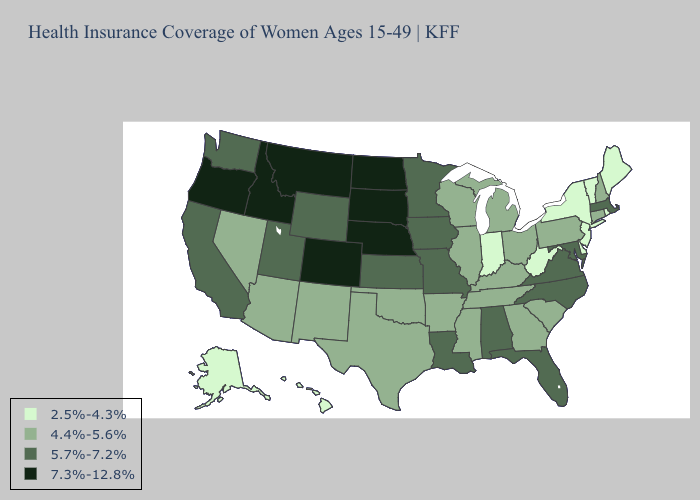What is the value of Illinois?
Concise answer only. 4.4%-5.6%. Does New York have the same value as New Hampshire?
Quick response, please. No. Which states have the highest value in the USA?
Short answer required. Colorado, Idaho, Montana, Nebraska, North Dakota, Oregon, South Dakota. What is the lowest value in the West?
Short answer required. 2.5%-4.3%. Name the states that have a value in the range 7.3%-12.8%?
Short answer required. Colorado, Idaho, Montana, Nebraska, North Dakota, Oregon, South Dakota. Does Pennsylvania have the highest value in the Northeast?
Quick response, please. No. Which states have the lowest value in the USA?
Short answer required. Alaska, Delaware, Hawaii, Indiana, Maine, New Jersey, New York, Rhode Island, Vermont, West Virginia. What is the lowest value in the Northeast?
Concise answer only. 2.5%-4.3%. Among the states that border Maryland , which have the lowest value?
Be succinct. Delaware, West Virginia. What is the value of Delaware?
Concise answer only. 2.5%-4.3%. What is the highest value in states that border Idaho?
Short answer required. 7.3%-12.8%. Among the states that border Massachusetts , does New York have the lowest value?
Write a very short answer. Yes. What is the value of Washington?
Write a very short answer. 5.7%-7.2%. Name the states that have a value in the range 2.5%-4.3%?
Give a very brief answer. Alaska, Delaware, Hawaii, Indiana, Maine, New Jersey, New York, Rhode Island, Vermont, West Virginia. What is the value of Florida?
Write a very short answer. 5.7%-7.2%. 